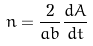<formula> <loc_0><loc_0><loc_500><loc_500>n = \frac { 2 } { a b } \frac { d A } { d t }</formula> 